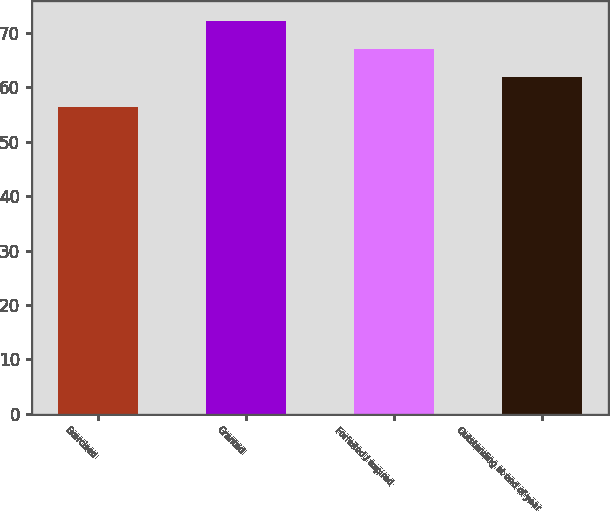<chart> <loc_0><loc_0><loc_500><loc_500><bar_chart><fcel>Exercised<fcel>Granted<fcel>Forfeited / expired<fcel>Outstanding at end of year<nl><fcel>56.44<fcel>72.18<fcel>67.09<fcel>61.84<nl></chart> 